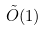<formula> <loc_0><loc_0><loc_500><loc_500>\tilde { O } ( 1 )</formula> 